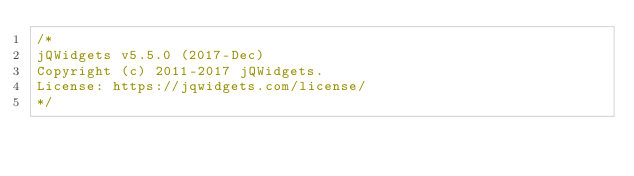<code> <loc_0><loc_0><loc_500><loc_500><_JavaScript_>/*
jQWidgets v5.5.0 (2017-Dec)
Copyright (c) 2011-2017 jQWidgets.
License: https://jqwidgets.com/license/
*/
</code> 